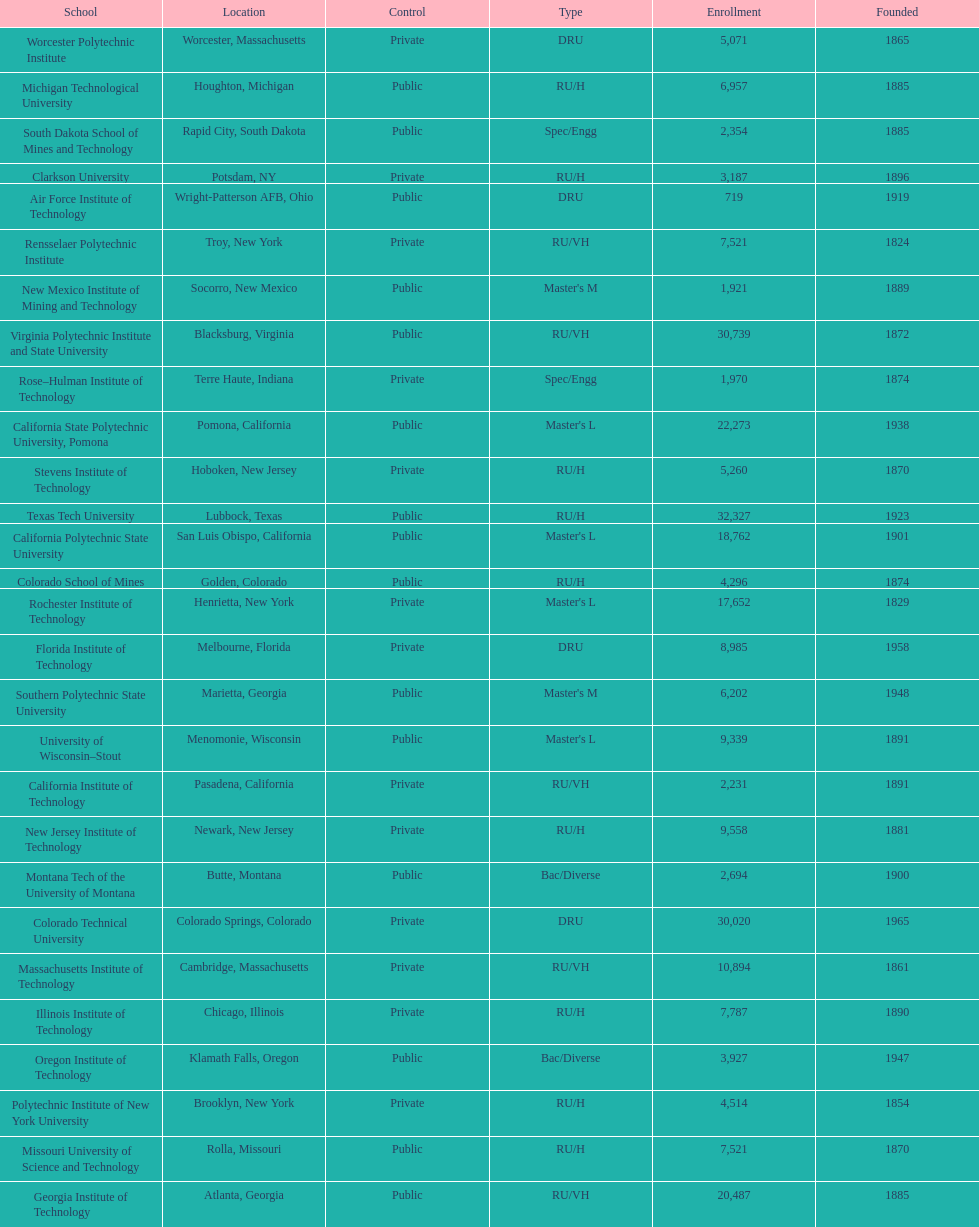Which school had the largest enrollment? Texas Tech University. 